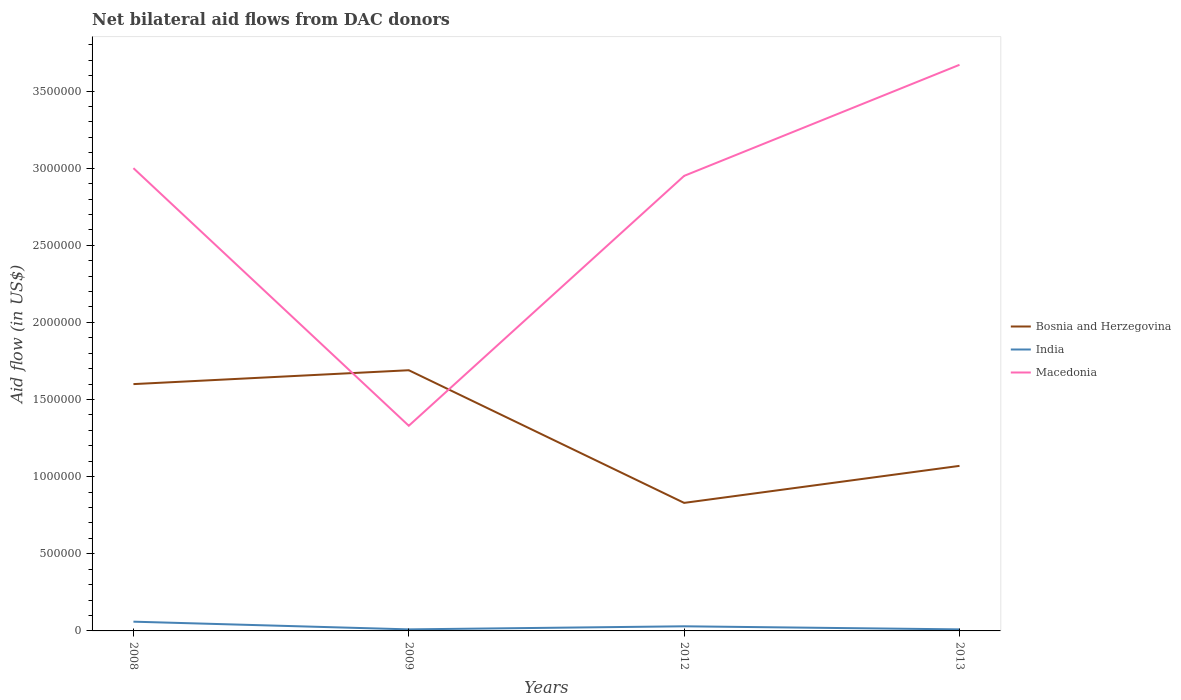Does the line corresponding to Macedonia intersect with the line corresponding to Bosnia and Herzegovina?
Offer a very short reply. Yes. Is the number of lines equal to the number of legend labels?
Offer a very short reply. Yes. Across all years, what is the maximum net bilateral aid flow in Macedonia?
Keep it short and to the point. 1.33e+06. What is the total net bilateral aid flow in Bosnia and Herzegovina in the graph?
Provide a succinct answer. 6.20e+05. What is the difference between the highest and the second highest net bilateral aid flow in India?
Your response must be concise. 5.00e+04. What is the difference between the highest and the lowest net bilateral aid flow in Bosnia and Herzegovina?
Your answer should be compact. 2. Is the net bilateral aid flow in Bosnia and Herzegovina strictly greater than the net bilateral aid flow in Macedonia over the years?
Offer a terse response. No. How many lines are there?
Ensure brevity in your answer.  3. How many years are there in the graph?
Your answer should be compact. 4. What is the difference between two consecutive major ticks on the Y-axis?
Keep it short and to the point. 5.00e+05. Are the values on the major ticks of Y-axis written in scientific E-notation?
Provide a short and direct response. No. Does the graph contain grids?
Provide a short and direct response. No. Where does the legend appear in the graph?
Your response must be concise. Center right. What is the title of the graph?
Keep it short and to the point. Net bilateral aid flows from DAC donors. Does "Ecuador" appear as one of the legend labels in the graph?
Your response must be concise. No. What is the label or title of the X-axis?
Give a very brief answer. Years. What is the label or title of the Y-axis?
Your answer should be compact. Aid flow (in US$). What is the Aid flow (in US$) of Bosnia and Herzegovina in 2008?
Keep it short and to the point. 1.60e+06. What is the Aid flow (in US$) in Bosnia and Herzegovina in 2009?
Keep it short and to the point. 1.69e+06. What is the Aid flow (in US$) of India in 2009?
Your response must be concise. 10000. What is the Aid flow (in US$) of Macedonia in 2009?
Offer a very short reply. 1.33e+06. What is the Aid flow (in US$) in Bosnia and Herzegovina in 2012?
Offer a very short reply. 8.30e+05. What is the Aid flow (in US$) of Macedonia in 2012?
Your response must be concise. 2.95e+06. What is the Aid flow (in US$) of Bosnia and Herzegovina in 2013?
Give a very brief answer. 1.07e+06. What is the Aid flow (in US$) of India in 2013?
Give a very brief answer. 10000. What is the Aid flow (in US$) in Macedonia in 2013?
Give a very brief answer. 3.67e+06. Across all years, what is the maximum Aid flow (in US$) of Bosnia and Herzegovina?
Your answer should be compact. 1.69e+06. Across all years, what is the maximum Aid flow (in US$) in India?
Keep it short and to the point. 6.00e+04. Across all years, what is the maximum Aid flow (in US$) of Macedonia?
Make the answer very short. 3.67e+06. Across all years, what is the minimum Aid flow (in US$) of Bosnia and Herzegovina?
Keep it short and to the point. 8.30e+05. Across all years, what is the minimum Aid flow (in US$) in Macedonia?
Keep it short and to the point. 1.33e+06. What is the total Aid flow (in US$) of Bosnia and Herzegovina in the graph?
Provide a short and direct response. 5.19e+06. What is the total Aid flow (in US$) of India in the graph?
Offer a terse response. 1.10e+05. What is the total Aid flow (in US$) of Macedonia in the graph?
Your answer should be very brief. 1.10e+07. What is the difference between the Aid flow (in US$) in Macedonia in 2008 and that in 2009?
Your answer should be very brief. 1.67e+06. What is the difference between the Aid flow (in US$) of Bosnia and Herzegovina in 2008 and that in 2012?
Give a very brief answer. 7.70e+05. What is the difference between the Aid flow (in US$) of Macedonia in 2008 and that in 2012?
Offer a very short reply. 5.00e+04. What is the difference between the Aid flow (in US$) in Bosnia and Herzegovina in 2008 and that in 2013?
Give a very brief answer. 5.30e+05. What is the difference between the Aid flow (in US$) in India in 2008 and that in 2013?
Give a very brief answer. 5.00e+04. What is the difference between the Aid flow (in US$) in Macedonia in 2008 and that in 2013?
Your response must be concise. -6.70e+05. What is the difference between the Aid flow (in US$) in Bosnia and Herzegovina in 2009 and that in 2012?
Make the answer very short. 8.60e+05. What is the difference between the Aid flow (in US$) of India in 2009 and that in 2012?
Make the answer very short. -2.00e+04. What is the difference between the Aid flow (in US$) of Macedonia in 2009 and that in 2012?
Make the answer very short. -1.62e+06. What is the difference between the Aid flow (in US$) of Bosnia and Herzegovina in 2009 and that in 2013?
Ensure brevity in your answer.  6.20e+05. What is the difference between the Aid flow (in US$) of Macedonia in 2009 and that in 2013?
Keep it short and to the point. -2.34e+06. What is the difference between the Aid flow (in US$) of India in 2012 and that in 2013?
Keep it short and to the point. 2.00e+04. What is the difference between the Aid flow (in US$) in Macedonia in 2012 and that in 2013?
Keep it short and to the point. -7.20e+05. What is the difference between the Aid flow (in US$) in Bosnia and Herzegovina in 2008 and the Aid flow (in US$) in India in 2009?
Offer a terse response. 1.59e+06. What is the difference between the Aid flow (in US$) in India in 2008 and the Aid flow (in US$) in Macedonia in 2009?
Provide a short and direct response. -1.27e+06. What is the difference between the Aid flow (in US$) in Bosnia and Herzegovina in 2008 and the Aid flow (in US$) in India in 2012?
Provide a short and direct response. 1.57e+06. What is the difference between the Aid flow (in US$) in Bosnia and Herzegovina in 2008 and the Aid flow (in US$) in Macedonia in 2012?
Make the answer very short. -1.35e+06. What is the difference between the Aid flow (in US$) of India in 2008 and the Aid flow (in US$) of Macedonia in 2012?
Your answer should be compact. -2.89e+06. What is the difference between the Aid flow (in US$) in Bosnia and Herzegovina in 2008 and the Aid flow (in US$) in India in 2013?
Your response must be concise. 1.59e+06. What is the difference between the Aid flow (in US$) in Bosnia and Herzegovina in 2008 and the Aid flow (in US$) in Macedonia in 2013?
Offer a very short reply. -2.07e+06. What is the difference between the Aid flow (in US$) of India in 2008 and the Aid flow (in US$) of Macedonia in 2013?
Keep it short and to the point. -3.61e+06. What is the difference between the Aid flow (in US$) in Bosnia and Herzegovina in 2009 and the Aid flow (in US$) in India in 2012?
Give a very brief answer. 1.66e+06. What is the difference between the Aid flow (in US$) in Bosnia and Herzegovina in 2009 and the Aid flow (in US$) in Macedonia in 2012?
Offer a terse response. -1.26e+06. What is the difference between the Aid flow (in US$) of India in 2009 and the Aid flow (in US$) of Macedonia in 2012?
Offer a very short reply. -2.94e+06. What is the difference between the Aid flow (in US$) in Bosnia and Herzegovina in 2009 and the Aid flow (in US$) in India in 2013?
Make the answer very short. 1.68e+06. What is the difference between the Aid flow (in US$) of Bosnia and Herzegovina in 2009 and the Aid flow (in US$) of Macedonia in 2013?
Ensure brevity in your answer.  -1.98e+06. What is the difference between the Aid flow (in US$) of India in 2009 and the Aid flow (in US$) of Macedonia in 2013?
Offer a very short reply. -3.66e+06. What is the difference between the Aid flow (in US$) of Bosnia and Herzegovina in 2012 and the Aid flow (in US$) of India in 2013?
Give a very brief answer. 8.20e+05. What is the difference between the Aid flow (in US$) of Bosnia and Herzegovina in 2012 and the Aid flow (in US$) of Macedonia in 2013?
Your answer should be very brief. -2.84e+06. What is the difference between the Aid flow (in US$) in India in 2012 and the Aid flow (in US$) in Macedonia in 2013?
Your answer should be compact. -3.64e+06. What is the average Aid flow (in US$) in Bosnia and Herzegovina per year?
Give a very brief answer. 1.30e+06. What is the average Aid flow (in US$) of India per year?
Offer a very short reply. 2.75e+04. What is the average Aid flow (in US$) of Macedonia per year?
Your response must be concise. 2.74e+06. In the year 2008, what is the difference between the Aid flow (in US$) of Bosnia and Herzegovina and Aid flow (in US$) of India?
Offer a very short reply. 1.54e+06. In the year 2008, what is the difference between the Aid flow (in US$) of Bosnia and Herzegovina and Aid flow (in US$) of Macedonia?
Provide a short and direct response. -1.40e+06. In the year 2008, what is the difference between the Aid flow (in US$) in India and Aid flow (in US$) in Macedonia?
Make the answer very short. -2.94e+06. In the year 2009, what is the difference between the Aid flow (in US$) of Bosnia and Herzegovina and Aid flow (in US$) of India?
Ensure brevity in your answer.  1.68e+06. In the year 2009, what is the difference between the Aid flow (in US$) in Bosnia and Herzegovina and Aid flow (in US$) in Macedonia?
Give a very brief answer. 3.60e+05. In the year 2009, what is the difference between the Aid flow (in US$) of India and Aid flow (in US$) of Macedonia?
Give a very brief answer. -1.32e+06. In the year 2012, what is the difference between the Aid flow (in US$) of Bosnia and Herzegovina and Aid flow (in US$) of Macedonia?
Provide a succinct answer. -2.12e+06. In the year 2012, what is the difference between the Aid flow (in US$) in India and Aid flow (in US$) in Macedonia?
Offer a very short reply. -2.92e+06. In the year 2013, what is the difference between the Aid flow (in US$) in Bosnia and Herzegovina and Aid flow (in US$) in India?
Provide a succinct answer. 1.06e+06. In the year 2013, what is the difference between the Aid flow (in US$) in Bosnia and Herzegovina and Aid flow (in US$) in Macedonia?
Provide a succinct answer. -2.60e+06. In the year 2013, what is the difference between the Aid flow (in US$) of India and Aid flow (in US$) of Macedonia?
Give a very brief answer. -3.66e+06. What is the ratio of the Aid flow (in US$) in Bosnia and Herzegovina in 2008 to that in 2009?
Give a very brief answer. 0.95. What is the ratio of the Aid flow (in US$) in India in 2008 to that in 2009?
Provide a short and direct response. 6. What is the ratio of the Aid flow (in US$) of Macedonia in 2008 to that in 2009?
Keep it short and to the point. 2.26. What is the ratio of the Aid flow (in US$) in Bosnia and Herzegovina in 2008 to that in 2012?
Ensure brevity in your answer.  1.93. What is the ratio of the Aid flow (in US$) of India in 2008 to that in 2012?
Provide a succinct answer. 2. What is the ratio of the Aid flow (in US$) of Macedonia in 2008 to that in 2012?
Make the answer very short. 1.02. What is the ratio of the Aid flow (in US$) of Bosnia and Herzegovina in 2008 to that in 2013?
Give a very brief answer. 1.5. What is the ratio of the Aid flow (in US$) of Macedonia in 2008 to that in 2013?
Offer a terse response. 0.82. What is the ratio of the Aid flow (in US$) in Bosnia and Herzegovina in 2009 to that in 2012?
Keep it short and to the point. 2.04. What is the ratio of the Aid flow (in US$) of Macedonia in 2009 to that in 2012?
Ensure brevity in your answer.  0.45. What is the ratio of the Aid flow (in US$) of Bosnia and Herzegovina in 2009 to that in 2013?
Offer a very short reply. 1.58. What is the ratio of the Aid flow (in US$) in Macedonia in 2009 to that in 2013?
Give a very brief answer. 0.36. What is the ratio of the Aid flow (in US$) of Bosnia and Herzegovina in 2012 to that in 2013?
Give a very brief answer. 0.78. What is the ratio of the Aid flow (in US$) of India in 2012 to that in 2013?
Keep it short and to the point. 3. What is the ratio of the Aid flow (in US$) in Macedonia in 2012 to that in 2013?
Your answer should be compact. 0.8. What is the difference between the highest and the second highest Aid flow (in US$) in Macedonia?
Give a very brief answer. 6.70e+05. What is the difference between the highest and the lowest Aid flow (in US$) in Bosnia and Herzegovina?
Make the answer very short. 8.60e+05. What is the difference between the highest and the lowest Aid flow (in US$) in India?
Your response must be concise. 5.00e+04. What is the difference between the highest and the lowest Aid flow (in US$) of Macedonia?
Your response must be concise. 2.34e+06. 